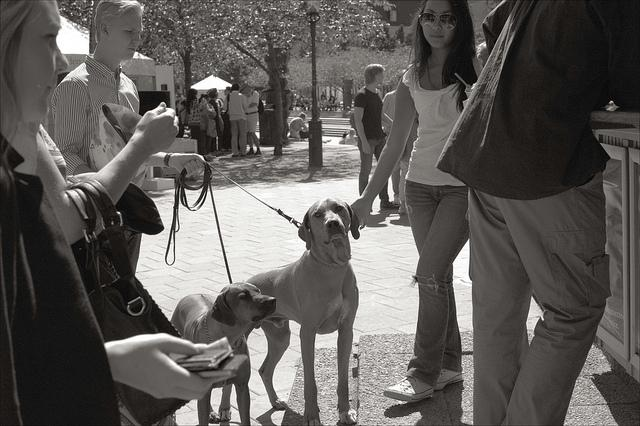How many dogs are held on the leashes? two 